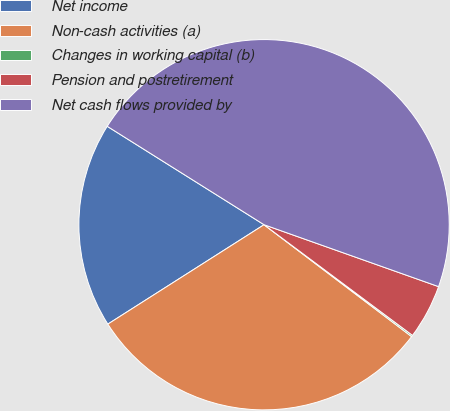Convert chart to OTSL. <chart><loc_0><loc_0><loc_500><loc_500><pie_chart><fcel>Net income<fcel>Non-cash activities (a)<fcel>Changes in working capital (b)<fcel>Pension and postretirement<fcel>Net cash flows provided by<nl><fcel>17.94%<fcel>30.66%<fcel>0.13%<fcel>4.77%<fcel>46.51%<nl></chart> 